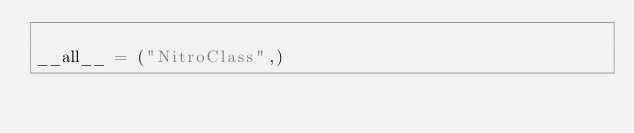<code> <loc_0><loc_0><loc_500><loc_500><_Python_>
__all__ = ("NitroClass",)</code> 